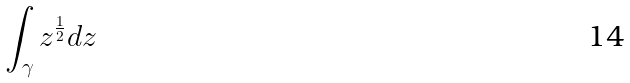Convert formula to latex. <formula><loc_0><loc_0><loc_500><loc_500>\int _ { \gamma } z ^ { \frac { 1 } { 2 } } d z</formula> 